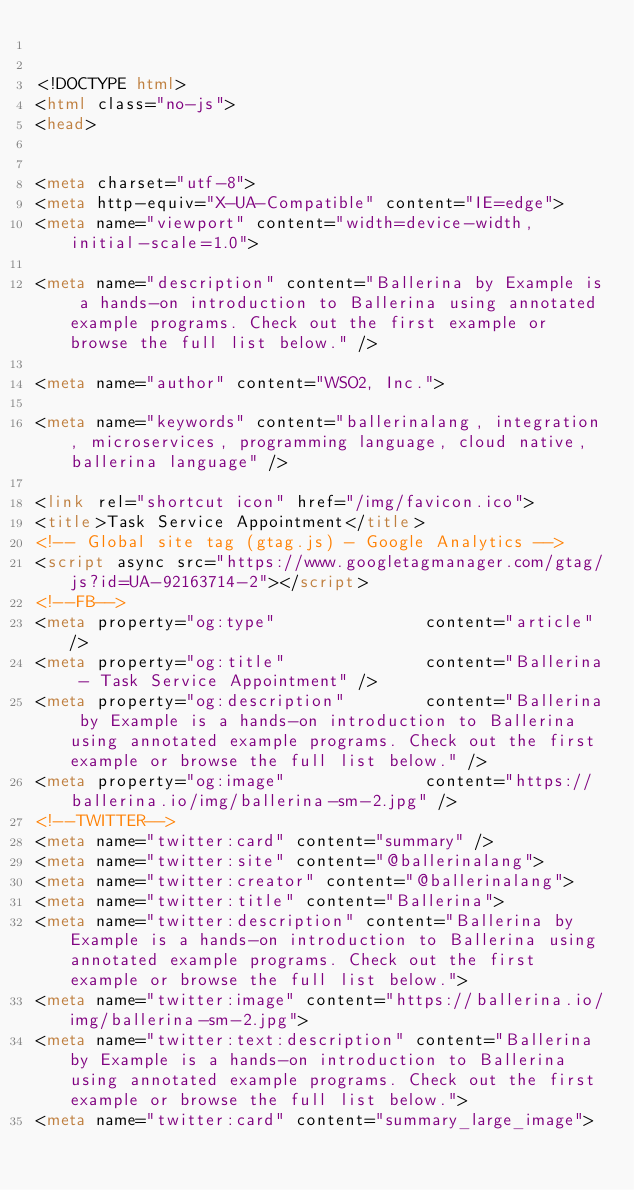<code> <loc_0><loc_0><loc_500><loc_500><_HTML_>

<!DOCTYPE html>
<html class="no-js">
<head>
    

<meta charset="utf-8">
<meta http-equiv="X-UA-Compatible" content="IE=edge">
<meta name="viewport" content="width=device-width, initial-scale=1.0">

<meta name="description" content="Ballerina by Example is a hands-on introduction to Ballerina using annotated example programs. Check out the first example or browse the full list below." />

<meta name="author" content="WSO2, Inc.">

<meta name="keywords" content="ballerinalang, integration, microservices, programming language, cloud native, ballerina language" />

<link rel="shortcut icon" href="/img/favicon.ico">
<title>Task Service Appointment</title>
<!-- Global site tag (gtag.js) - Google Analytics -->
<script async src="https://www.googletagmanager.com/gtag/js?id=UA-92163714-2"></script>
<!--FB-->
<meta property="og:type"               content="article" />
<meta property="og:title"              content="Ballerina - Task Service Appointment" />
<meta property="og:description"        content="Ballerina by Example is a hands-on introduction to Ballerina using annotated example programs. Check out the first example or browse the full list below." />
<meta property="og:image"              content="https://ballerina.io/img/ballerina-sm-2.jpg" />
<!--TWITTER-->
<meta name="twitter:card" content="summary" />
<meta name="twitter:site" content="@ballerinalang">
<meta name="twitter:creator" content="@ballerinalang">
<meta name="twitter:title" content="Ballerina">
<meta name="twitter:description" content="Ballerina by Example is a hands-on introduction to Ballerina using annotated example programs. Check out the first example or browse the full list below.">
<meta name="twitter:image" content="https://ballerina.io/img/ballerina-sm-2.jpg">
<meta name="twitter:text:description" content="Ballerina by Example is a hands-on introduction to Ballerina using annotated example programs. Check out the first example or browse the full list below.">
<meta name="twitter:card" content="summary_large_image"></code> 